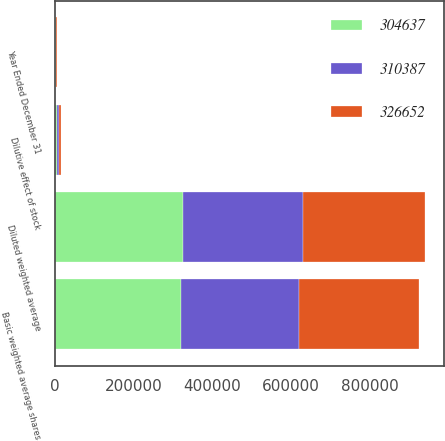Convert chart. <chart><loc_0><loc_0><loc_500><loc_500><stacked_bar_chart><ecel><fcel>Year Ended December 31<fcel>Basic weighted average shares<fcel>Dilutive effect of stock<fcel>Diluted weighted average<nl><fcel>310387<fcel>2017<fcel>299172<fcel>5465<fcel>304637<nl><fcel>326652<fcel>2016<fcel>304707<fcel>5680<fcel>310387<nl><fcel>304637<fcel>2015<fcel>321313<fcel>5339<fcel>326652<nl></chart> 